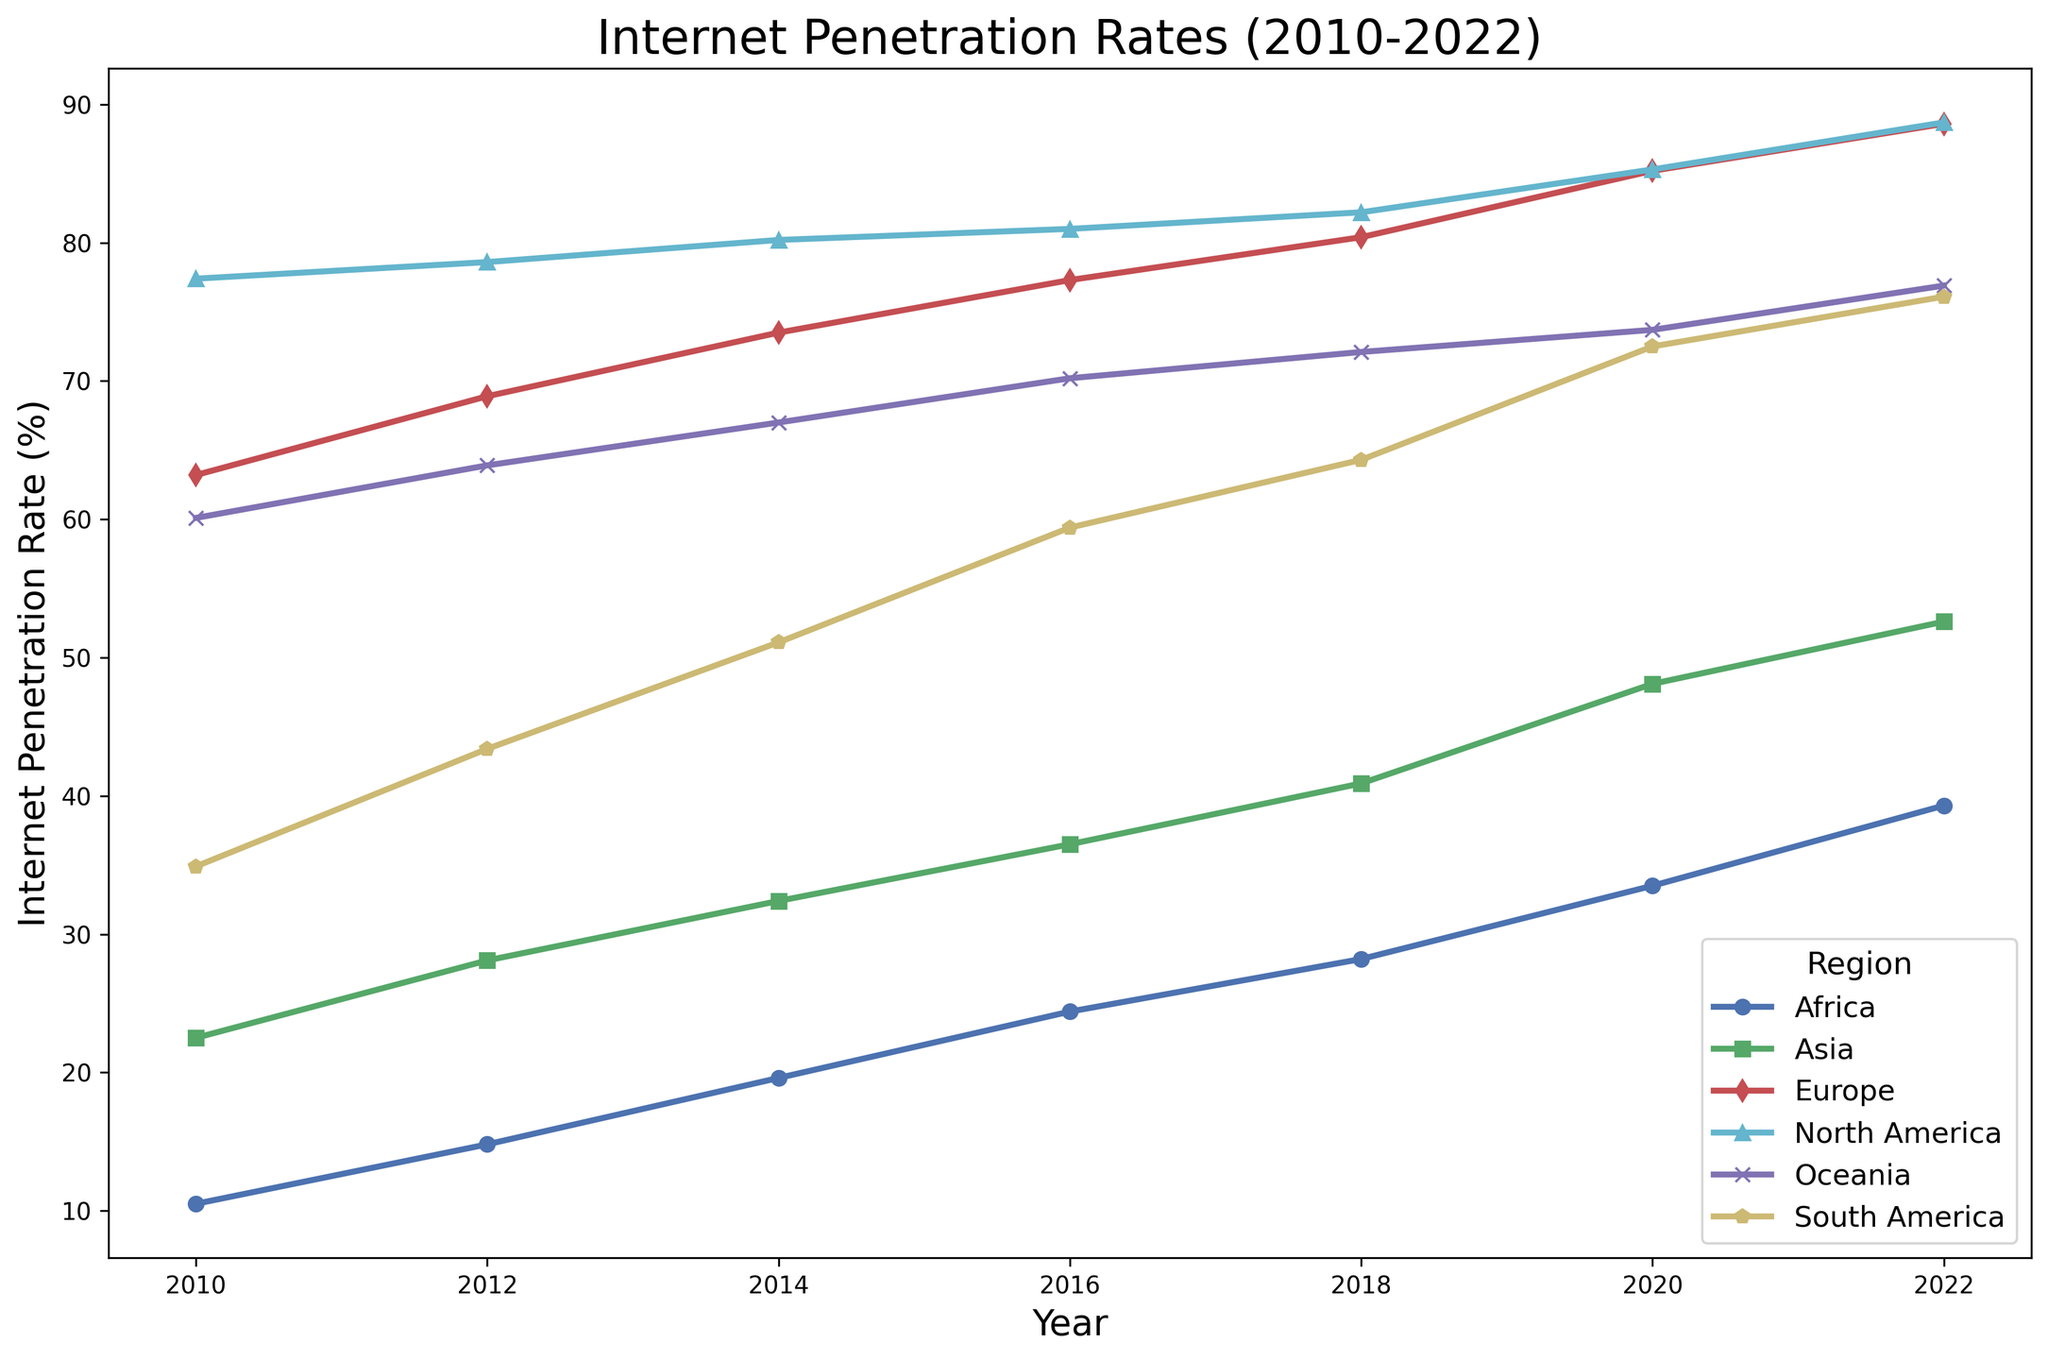What region had the highest internet penetration rate in 2022? To find the region with the highest internet penetration rate in 2022, look at the data points for each region in 2022 and identify the maximum value. 
North America had an internet penetration rate of 88.7% in 2022, which is the highest among all the regions.
Answer: North America Which region showed the largest increase in internet penetration rate from 2010 to 2022? Calculate the difference in internet penetration rates between 2010 and 2022 for each region. 
Africa: 39.3 - 10.5 = 28.8, Asia: 52.6 - 22.5 = 30.1, Europe: 88.6 - 63.2 = 25.4, North America: 88.7 - 77.4 = 11.3, Oceania: 76.9 - 60.1 = 16.8, South America: 76.1 - 34.9 = 41.2
South America had the largest increase (41.2) in internet penetration rate from 2010 to 2022.
Answer: South America Which two regions had nearly equal internet penetration rates in 2020? Compare the internet penetration rates of all regions in 2020 to find similar values. 
Europe had 85.2% and North America had 85.3%, which are nearly equal.
Answer: Europe and North America What is the average internet penetration rate for Asia from 2010 to 2022? Sum the internet penetration rates for Asia from 2010 to 2022 and divide by the number of years (7). 
(22.5 + 28.1 + 32.4 + 36.5 + 40.9 + 48.1 + 52.6) / 7 ≈ 37.3
Answer: ~37.3% How did the internet penetration rate in Africa change from 2014 to 2018? Subtract Africa's internet penetration rate in 2014 from that in 2018. 
28.2% (2018) - 19.6% (2014) = 8.6% increase.
Answer: 8.6% increase Which region had a penetration rate of approximately 60% in 2010, and how did it change by 2018? In 2010, Oceania had an internet penetration rate of 60.1%. Examine Oceania's rate in 2018 to see the change.
Oceania's internet penetration rate was 72.1% in 2018. Change: 72.1% - 60.1% = 12%.
Answer: Oceania; 12% increase In which year did South America’s internet penetration rate surpass 50% for the first time? Observe the trend lines for South America and identify the year where the penetration rate surpasses 50% for the first time.
South America's internet penetration rate surpassed 50% in 2014.
Answer: 2014 Compare the internet penetration rate growth for Europe and North America from 2010 to 2022. Calculate the growth for both regions by finding the difference between 2010 and 2022 rates.
Europe: 88.6 - 63.2 = 25.4, North America: 88.7 - 77.4 = 11.3
Europe showed a growth of 25.4 percentage points, while North America grew by 11.3 percentage points.
Answer: Europe had higher growth How does the trend of internet penetration rate from 2016 to 2020 differ between Africa and Asia? Examine the trend lines for Africa and Asia between 2016 and 2020.
Africa shows a relatively steady increase from 24.4% to 33.5%, while Asia also shows steady growth from 36.5% to 48.1%, but at a slightly higher rate.
Both regions show increasing trends, but Asia’s growth is larger in magnitude.
Answer: Asia had a larger increase Which region had the smallest increase in internet penetration rate from 2010 to 2022? Find the difference between 2010 and 2022 rates for each region and identify the smallest value.
Africa: 28.8, Asia: 30.1, Europe: 25.4, North America: 11.3, Oceania: 16.8, South America: 41.2
North America had the smallest increase (11.3).
Answer: North America 